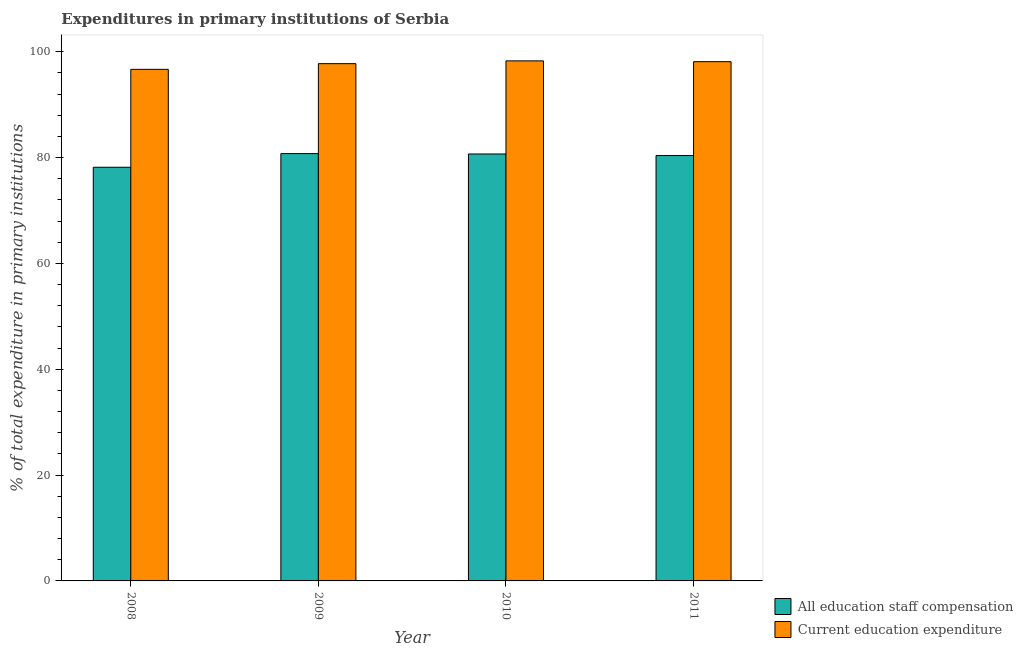How many different coloured bars are there?
Offer a terse response. 2. Are the number of bars per tick equal to the number of legend labels?
Your response must be concise. Yes. What is the expenditure in staff compensation in 2008?
Keep it short and to the point. 78.18. Across all years, what is the maximum expenditure in education?
Provide a short and direct response. 98.28. Across all years, what is the minimum expenditure in staff compensation?
Give a very brief answer. 78.18. What is the total expenditure in staff compensation in the graph?
Offer a terse response. 320.02. What is the difference between the expenditure in staff compensation in 2008 and that in 2011?
Your response must be concise. -2.22. What is the difference between the expenditure in staff compensation in 2011 and the expenditure in education in 2008?
Your answer should be very brief. 2.22. What is the average expenditure in education per year?
Ensure brevity in your answer.  97.71. What is the ratio of the expenditure in education in 2008 to that in 2011?
Your answer should be compact. 0.99. What is the difference between the highest and the second highest expenditure in staff compensation?
Ensure brevity in your answer.  0.08. What is the difference between the highest and the lowest expenditure in education?
Offer a terse response. 1.6. Is the sum of the expenditure in education in 2008 and 2010 greater than the maximum expenditure in staff compensation across all years?
Keep it short and to the point. Yes. What does the 2nd bar from the left in 2010 represents?
Ensure brevity in your answer.  Current education expenditure. What does the 2nd bar from the right in 2010 represents?
Offer a terse response. All education staff compensation. How many bars are there?
Your answer should be very brief. 8. Are the values on the major ticks of Y-axis written in scientific E-notation?
Give a very brief answer. No. Does the graph contain grids?
Give a very brief answer. No. Where does the legend appear in the graph?
Offer a very short reply. Bottom right. How many legend labels are there?
Give a very brief answer. 2. How are the legend labels stacked?
Offer a terse response. Vertical. What is the title of the graph?
Your answer should be very brief. Expenditures in primary institutions of Serbia. What is the label or title of the X-axis?
Ensure brevity in your answer.  Year. What is the label or title of the Y-axis?
Your answer should be compact. % of total expenditure in primary institutions. What is the % of total expenditure in primary institutions of All education staff compensation in 2008?
Offer a terse response. 78.18. What is the % of total expenditure in primary institutions of Current education expenditure in 2008?
Give a very brief answer. 96.68. What is the % of total expenditure in primary institutions in All education staff compensation in 2009?
Keep it short and to the point. 80.76. What is the % of total expenditure in primary institutions of Current education expenditure in 2009?
Offer a very short reply. 97.76. What is the % of total expenditure in primary institutions in All education staff compensation in 2010?
Offer a very short reply. 80.69. What is the % of total expenditure in primary institutions of Current education expenditure in 2010?
Give a very brief answer. 98.28. What is the % of total expenditure in primary institutions of All education staff compensation in 2011?
Ensure brevity in your answer.  80.39. What is the % of total expenditure in primary institutions of Current education expenditure in 2011?
Provide a succinct answer. 98.13. Across all years, what is the maximum % of total expenditure in primary institutions in All education staff compensation?
Offer a terse response. 80.76. Across all years, what is the maximum % of total expenditure in primary institutions in Current education expenditure?
Offer a terse response. 98.28. Across all years, what is the minimum % of total expenditure in primary institutions in All education staff compensation?
Keep it short and to the point. 78.18. Across all years, what is the minimum % of total expenditure in primary institutions in Current education expenditure?
Make the answer very short. 96.68. What is the total % of total expenditure in primary institutions of All education staff compensation in the graph?
Ensure brevity in your answer.  320.02. What is the total % of total expenditure in primary institutions in Current education expenditure in the graph?
Provide a succinct answer. 390.85. What is the difference between the % of total expenditure in primary institutions in All education staff compensation in 2008 and that in 2009?
Provide a succinct answer. -2.59. What is the difference between the % of total expenditure in primary institutions in Current education expenditure in 2008 and that in 2009?
Provide a short and direct response. -1.08. What is the difference between the % of total expenditure in primary institutions in All education staff compensation in 2008 and that in 2010?
Offer a terse response. -2.51. What is the difference between the % of total expenditure in primary institutions in Current education expenditure in 2008 and that in 2010?
Your answer should be very brief. -1.6. What is the difference between the % of total expenditure in primary institutions in All education staff compensation in 2008 and that in 2011?
Ensure brevity in your answer.  -2.22. What is the difference between the % of total expenditure in primary institutions of Current education expenditure in 2008 and that in 2011?
Your answer should be compact. -1.45. What is the difference between the % of total expenditure in primary institutions in All education staff compensation in 2009 and that in 2010?
Make the answer very short. 0.08. What is the difference between the % of total expenditure in primary institutions of Current education expenditure in 2009 and that in 2010?
Offer a terse response. -0.53. What is the difference between the % of total expenditure in primary institutions in All education staff compensation in 2009 and that in 2011?
Give a very brief answer. 0.37. What is the difference between the % of total expenditure in primary institutions in Current education expenditure in 2009 and that in 2011?
Offer a terse response. -0.37. What is the difference between the % of total expenditure in primary institutions in All education staff compensation in 2010 and that in 2011?
Provide a short and direct response. 0.29. What is the difference between the % of total expenditure in primary institutions of Current education expenditure in 2010 and that in 2011?
Keep it short and to the point. 0.15. What is the difference between the % of total expenditure in primary institutions of All education staff compensation in 2008 and the % of total expenditure in primary institutions of Current education expenditure in 2009?
Ensure brevity in your answer.  -19.58. What is the difference between the % of total expenditure in primary institutions in All education staff compensation in 2008 and the % of total expenditure in primary institutions in Current education expenditure in 2010?
Ensure brevity in your answer.  -20.11. What is the difference between the % of total expenditure in primary institutions of All education staff compensation in 2008 and the % of total expenditure in primary institutions of Current education expenditure in 2011?
Make the answer very short. -19.95. What is the difference between the % of total expenditure in primary institutions of All education staff compensation in 2009 and the % of total expenditure in primary institutions of Current education expenditure in 2010?
Give a very brief answer. -17.52. What is the difference between the % of total expenditure in primary institutions of All education staff compensation in 2009 and the % of total expenditure in primary institutions of Current education expenditure in 2011?
Offer a terse response. -17.37. What is the difference between the % of total expenditure in primary institutions of All education staff compensation in 2010 and the % of total expenditure in primary institutions of Current education expenditure in 2011?
Make the answer very short. -17.44. What is the average % of total expenditure in primary institutions of All education staff compensation per year?
Your response must be concise. 80. What is the average % of total expenditure in primary institutions of Current education expenditure per year?
Offer a terse response. 97.71. In the year 2008, what is the difference between the % of total expenditure in primary institutions in All education staff compensation and % of total expenditure in primary institutions in Current education expenditure?
Give a very brief answer. -18.5. In the year 2009, what is the difference between the % of total expenditure in primary institutions of All education staff compensation and % of total expenditure in primary institutions of Current education expenditure?
Keep it short and to the point. -16.99. In the year 2010, what is the difference between the % of total expenditure in primary institutions of All education staff compensation and % of total expenditure in primary institutions of Current education expenditure?
Keep it short and to the point. -17.6. In the year 2011, what is the difference between the % of total expenditure in primary institutions of All education staff compensation and % of total expenditure in primary institutions of Current education expenditure?
Make the answer very short. -17.74. What is the ratio of the % of total expenditure in primary institutions in All education staff compensation in 2008 to that in 2010?
Your response must be concise. 0.97. What is the ratio of the % of total expenditure in primary institutions in Current education expenditure in 2008 to that in 2010?
Offer a terse response. 0.98. What is the ratio of the % of total expenditure in primary institutions of All education staff compensation in 2008 to that in 2011?
Provide a short and direct response. 0.97. What is the ratio of the % of total expenditure in primary institutions of Current education expenditure in 2008 to that in 2011?
Offer a very short reply. 0.99. What is the ratio of the % of total expenditure in primary institutions in All education staff compensation in 2009 to that in 2010?
Give a very brief answer. 1. What is the ratio of the % of total expenditure in primary institutions in Current education expenditure in 2009 to that in 2011?
Provide a short and direct response. 1. What is the ratio of the % of total expenditure in primary institutions in Current education expenditure in 2010 to that in 2011?
Keep it short and to the point. 1. What is the difference between the highest and the second highest % of total expenditure in primary institutions of All education staff compensation?
Offer a very short reply. 0.08. What is the difference between the highest and the second highest % of total expenditure in primary institutions in Current education expenditure?
Keep it short and to the point. 0.15. What is the difference between the highest and the lowest % of total expenditure in primary institutions in All education staff compensation?
Ensure brevity in your answer.  2.59. What is the difference between the highest and the lowest % of total expenditure in primary institutions of Current education expenditure?
Provide a succinct answer. 1.6. 